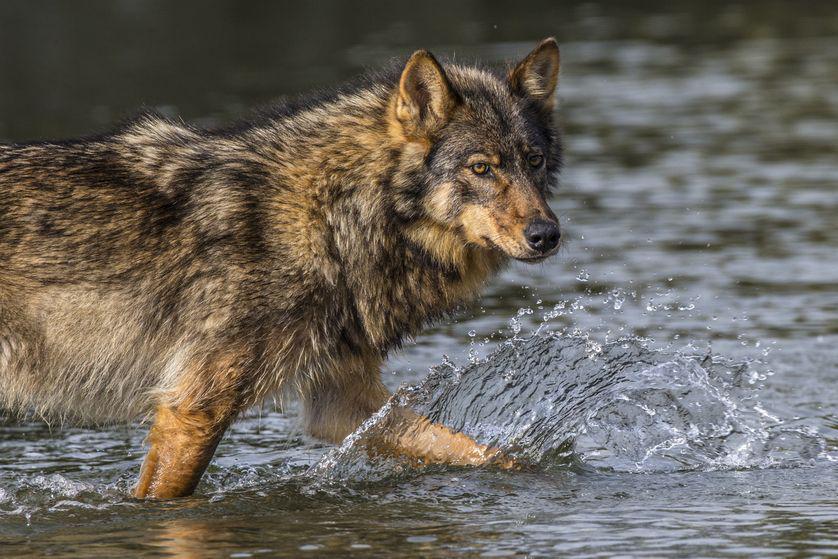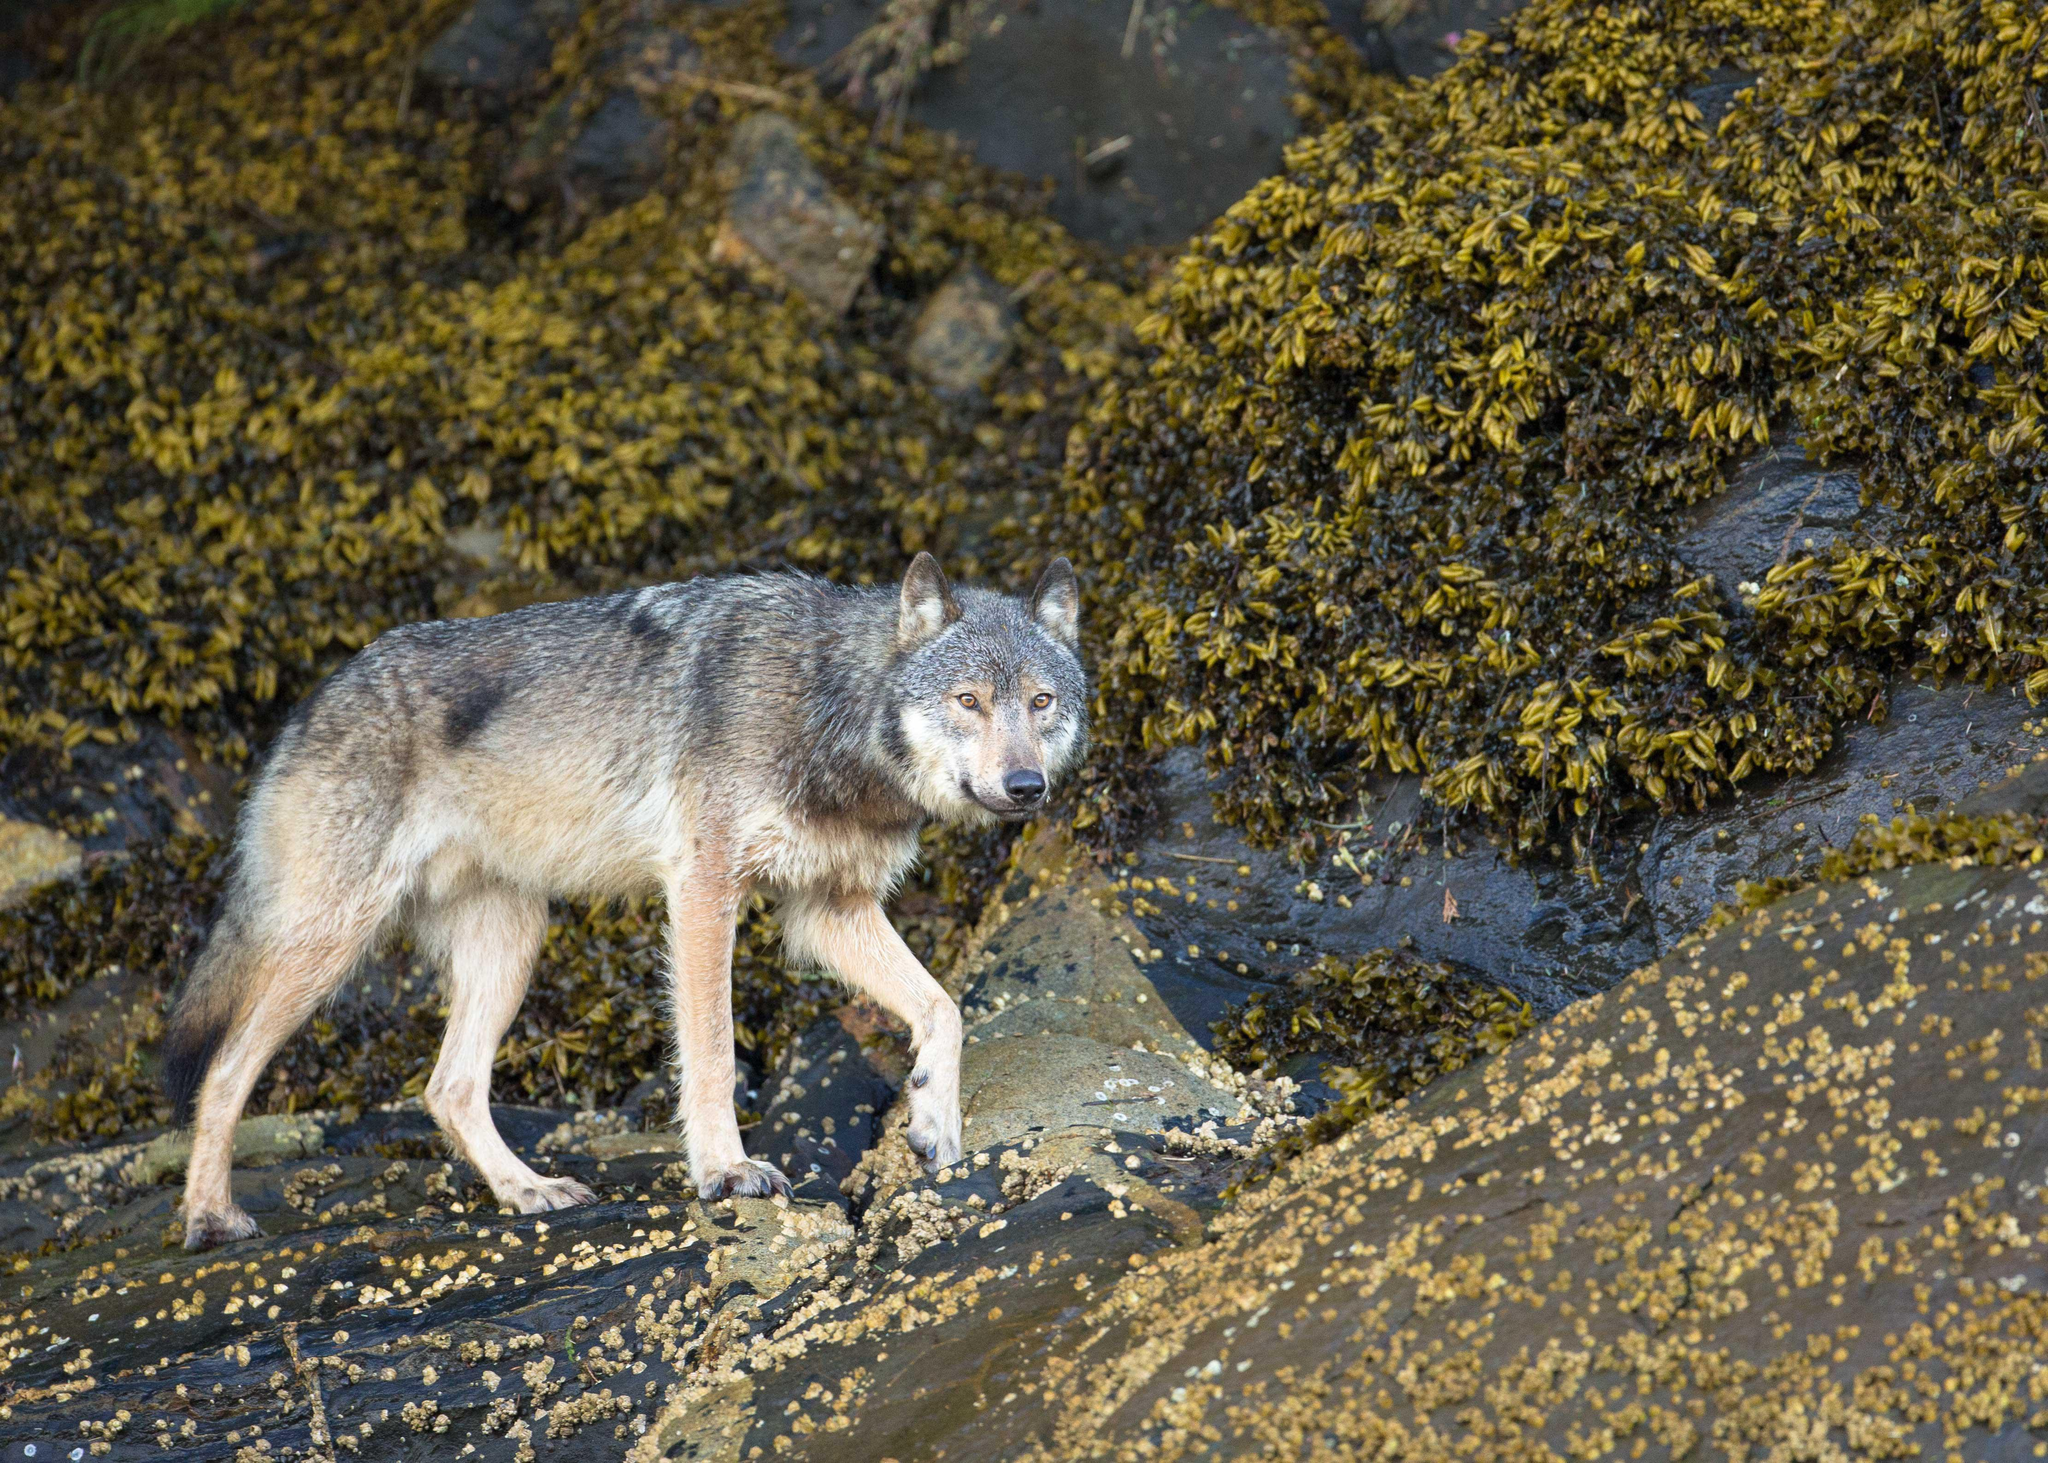The first image is the image on the left, the second image is the image on the right. For the images shown, is this caption "There is a total of 1 adult wolf laying down." true? Answer yes or no. No. The first image is the image on the left, the second image is the image on the right. Considering the images on both sides, is "A wolf is lying down in one picture and standing in the other." valid? Answer yes or no. No. 